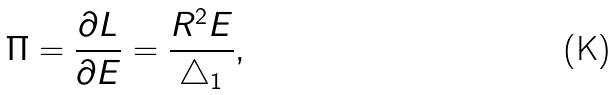<formula> <loc_0><loc_0><loc_500><loc_500>\Pi = \frac { \partial L } { \partial E } = \frac { R ^ { 2 } E } { \bigtriangleup _ { 1 } } ,</formula> 